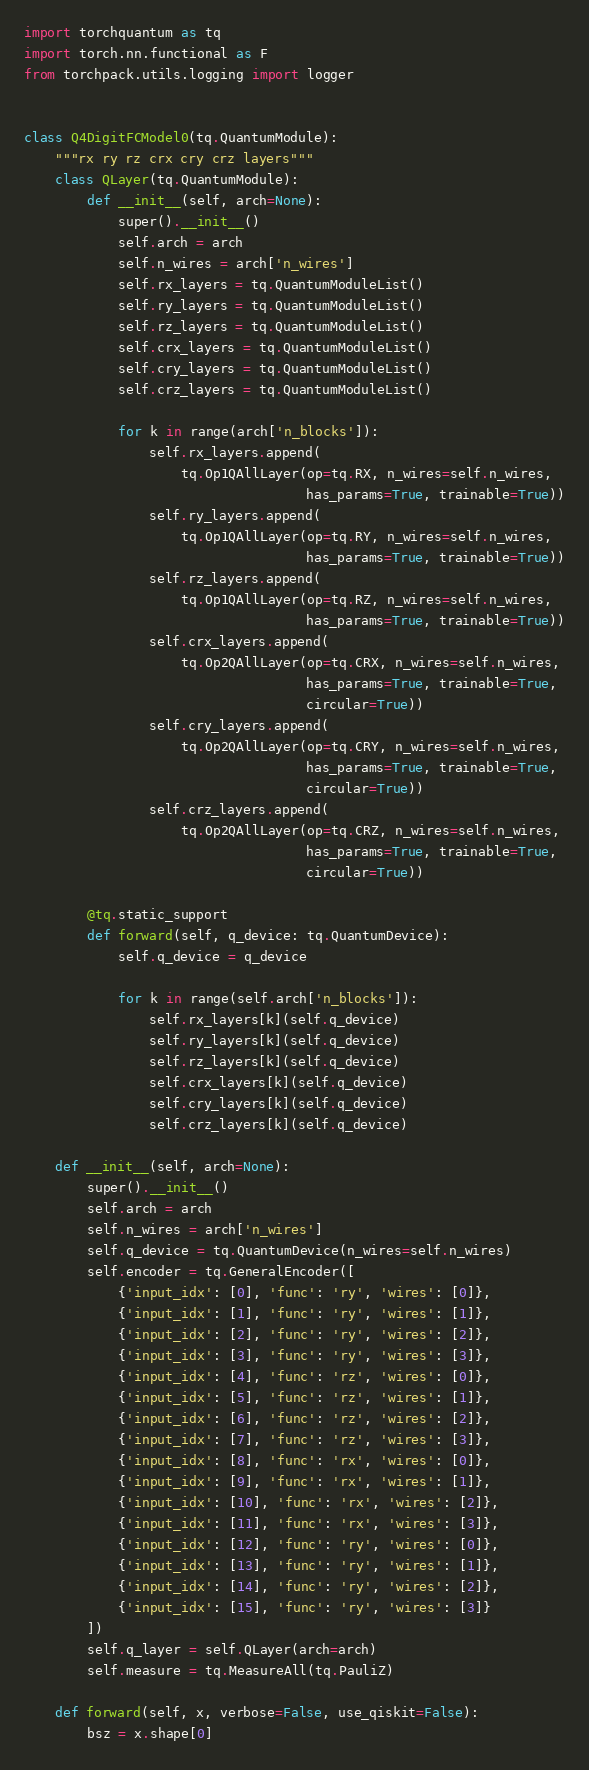<code> <loc_0><loc_0><loc_500><loc_500><_Python_>import torchquantum as tq
import torch.nn.functional as F
from torchpack.utils.logging import logger


class Q4DigitFCModel0(tq.QuantumModule):
    """rx ry rz crx cry crz layers"""
    class QLayer(tq.QuantumModule):
        def __init__(self, arch=None):
            super().__init__()
            self.arch = arch
            self.n_wires = arch['n_wires']
            self.rx_layers = tq.QuantumModuleList()
            self.ry_layers = tq.QuantumModuleList()
            self.rz_layers = tq.QuantumModuleList()
            self.crx_layers = tq.QuantumModuleList()
            self.cry_layers = tq.QuantumModuleList()
            self.crz_layers = tq.QuantumModuleList()

            for k in range(arch['n_blocks']):
                self.rx_layers.append(
                    tq.Op1QAllLayer(op=tq.RX, n_wires=self.n_wires,
                                    has_params=True, trainable=True))
                self.ry_layers.append(
                    tq.Op1QAllLayer(op=tq.RY, n_wires=self.n_wires,
                                    has_params=True, trainable=True))
                self.rz_layers.append(
                    tq.Op1QAllLayer(op=tq.RZ, n_wires=self.n_wires,
                                    has_params=True, trainable=True))
                self.crx_layers.append(
                    tq.Op2QAllLayer(op=tq.CRX, n_wires=self.n_wires,
                                    has_params=True, trainable=True,
                                    circular=True))
                self.cry_layers.append(
                    tq.Op2QAllLayer(op=tq.CRY, n_wires=self.n_wires,
                                    has_params=True, trainable=True,
                                    circular=True))
                self.crz_layers.append(
                    tq.Op2QAllLayer(op=tq.CRZ, n_wires=self.n_wires,
                                    has_params=True, trainable=True,
                                    circular=True))

        @tq.static_support
        def forward(self, q_device: tq.QuantumDevice):
            self.q_device = q_device

            for k in range(self.arch['n_blocks']):
                self.rx_layers[k](self.q_device)
                self.ry_layers[k](self.q_device)
                self.rz_layers[k](self.q_device)
                self.crx_layers[k](self.q_device)
                self.cry_layers[k](self.q_device)
                self.crz_layers[k](self.q_device)

    def __init__(self, arch=None):
        super().__init__()
        self.arch = arch
        self.n_wires = arch['n_wires']
        self.q_device = tq.QuantumDevice(n_wires=self.n_wires)
        self.encoder = tq.GeneralEncoder([
            {'input_idx': [0], 'func': 'ry', 'wires': [0]},
            {'input_idx': [1], 'func': 'ry', 'wires': [1]},
            {'input_idx': [2], 'func': 'ry', 'wires': [2]},
            {'input_idx': [3], 'func': 'ry', 'wires': [3]},
            {'input_idx': [4], 'func': 'rz', 'wires': [0]},
            {'input_idx': [5], 'func': 'rz', 'wires': [1]},
            {'input_idx': [6], 'func': 'rz', 'wires': [2]},
            {'input_idx': [7], 'func': 'rz', 'wires': [3]},
            {'input_idx': [8], 'func': 'rx', 'wires': [0]},
            {'input_idx': [9], 'func': 'rx', 'wires': [1]},
            {'input_idx': [10], 'func': 'rx', 'wires': [2]},
            {'input_idx': [11], 'func': 'rx', 'wires': [3]},
            {'input_idx': [12], 'func': 'ry', 'wires': [0]},
            {'input_idx': [13], 'func': 'ry', 'wires': [1]},
            {'input_idx': [14], 'func': 'ry', 'wires': [2]},
            {'input_idx': [15], 'func': 'ry', 'wires': [3]}
        ])
        self.q_layer = self.QLayer(arch=arch)
        self.measure = tq.MeasureAll(tq.PauliZ)

    def forward(self, x, verbose=False, use_qiskit=False):
        bsz = x.shape[0]</code> 